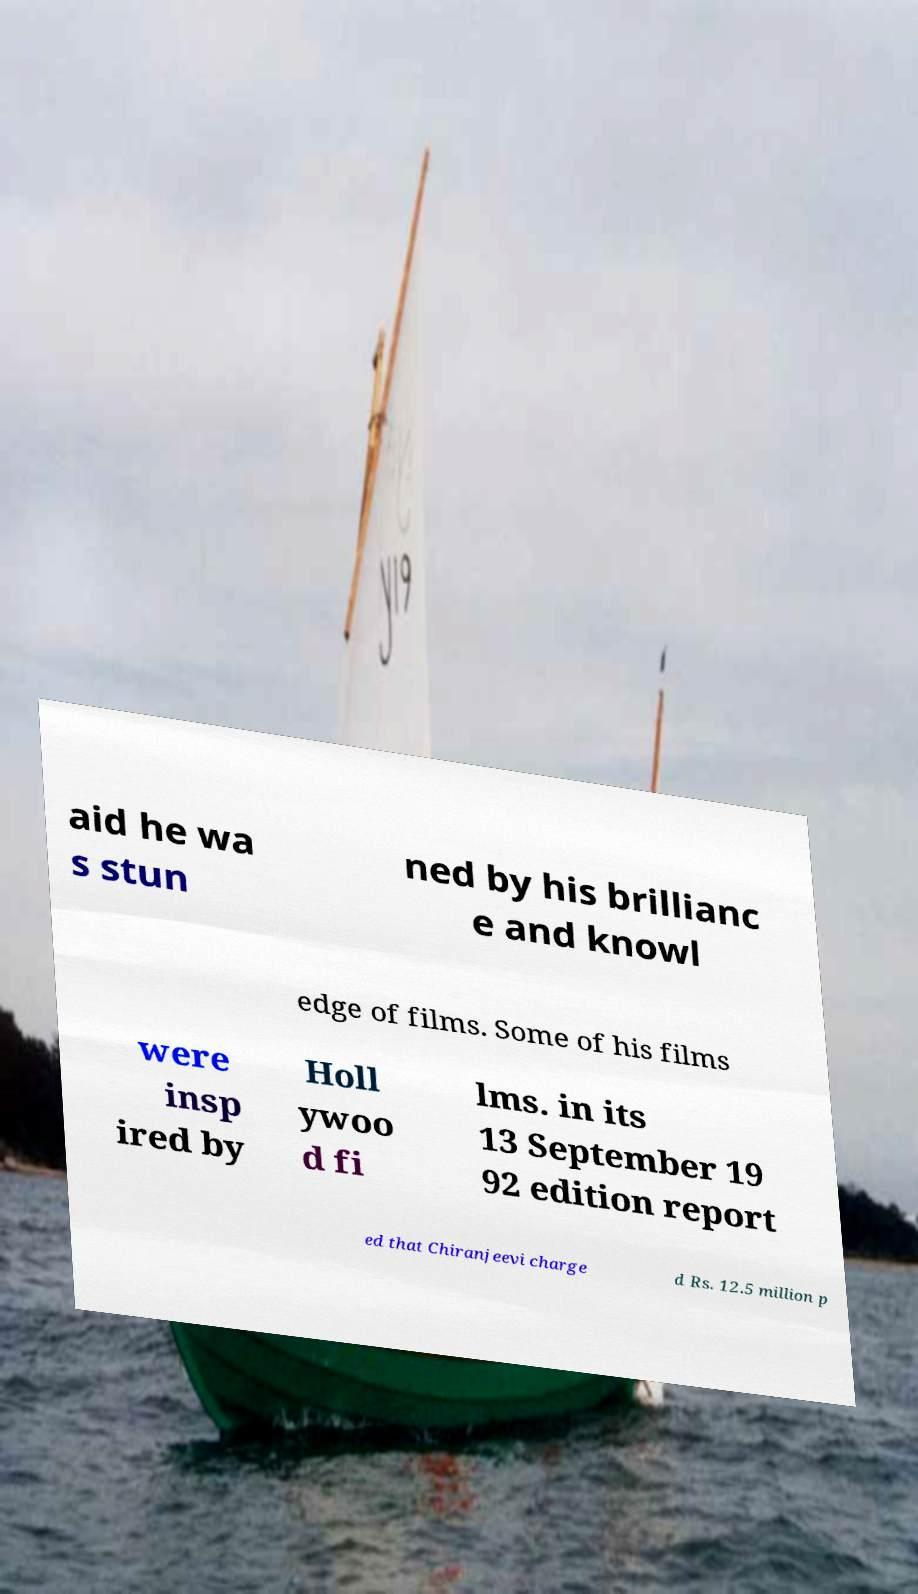Can you read and provide the text displayed in the image?This photo seems to have some interesting text. Can you extract and type it out for me? aid he wa s stun ned by his brillianc e and knowl edge of films. Some of his films were insp ired by Holl ywoo d fi lms. in its 13 September 19 92 edition report ed that Chiranjeevi charge d Rs. 12.5 million p 